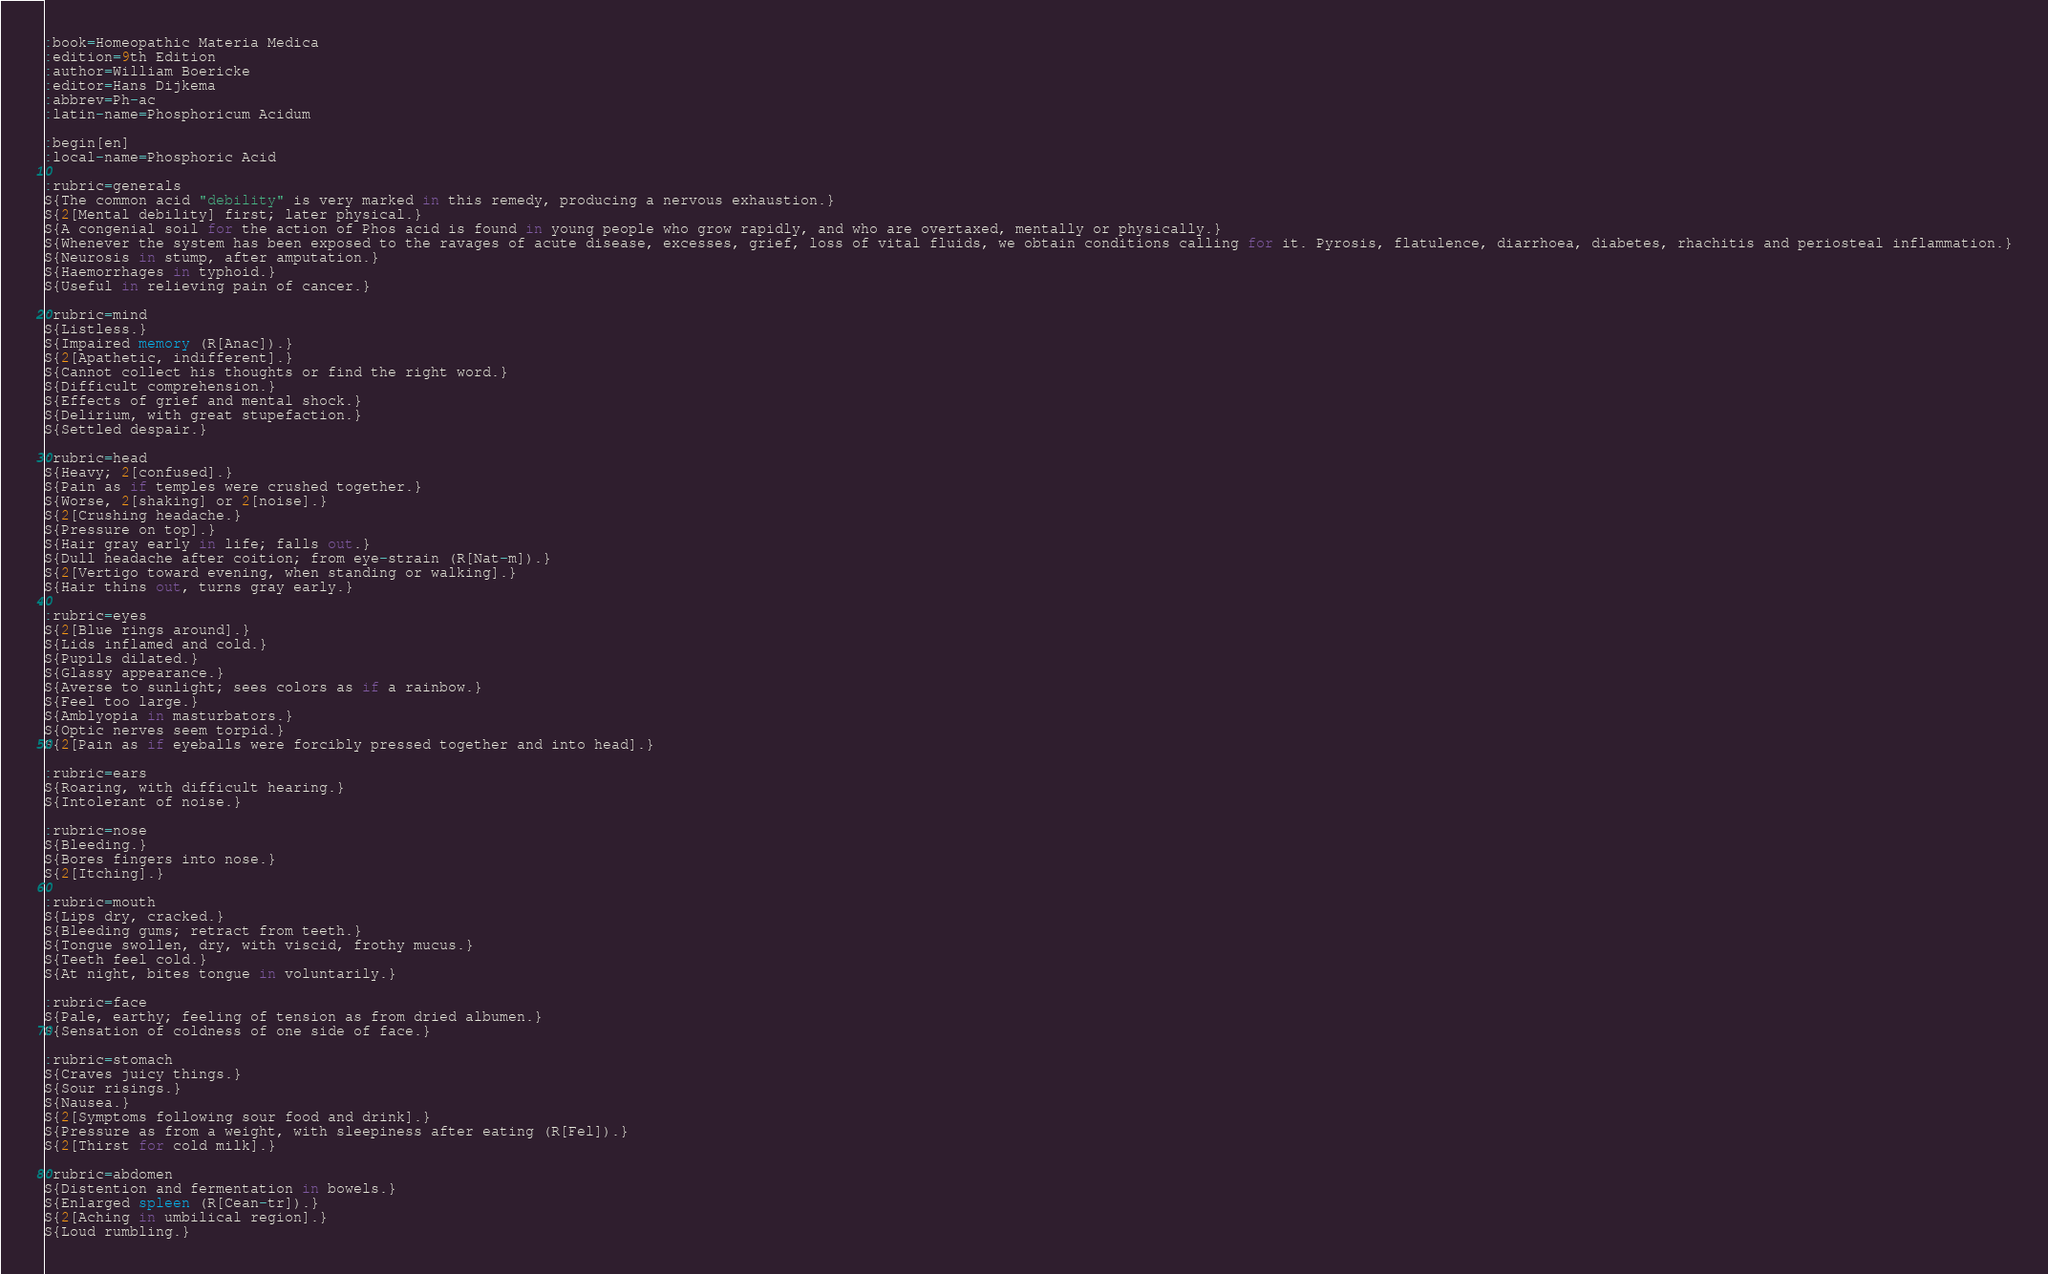Convert code to text. <code><loc_0><loc_0><loc_500><loc_500><_ObjectiveC_>:book=Homeopathic Materia Medica
:edition=9th Edition
:author=William Boericke
:editor=Hans Dijkema
:abbrev=Ph-ac
:latin-name=Phosphoricum Acidum

:begin[en]
:local-name=Phosphoric Acid

:rubric=generals
S{The common acid "debility" is very marked in this remedy, producing a nervous exhaustion.}
S{2[Mental debility] first; later physical.}
S{A congenial soil for the action of Phos acid is found in young people who grow rapidly, and who are overtaxed, mentally or physically.}
S{Whenever the system has been exposed to the ravages of acute disease, excesses, grief, loss of vital fluids, we obtain conditions calling for it. Pyrosis, flatulence, diarrhoea, diabetes, rhachitis and periosteal inflammation.}
S{Neurosis in stump, after amputation.}
S{Haemorrhages in typhoid.}
S{Useful in relieving pain of cancer.}

:rubric=mind
S{Listless.}
S{Impaired memory (R[Anac]).}
S{2[Apathetic, indifferent].}
S{Cannot collect his thoughts or find the right word.}
S{Difficult comprehension.}
S{Effects of grief and mental shock.}
S{Delirium, with great stupefaction.}
S{Settled despair.}

:rubric=head
S{Heavy; 2[confused].}
S{Pain as if temples were crushed together.}
S{Worse, 2[shaking] or 2[noise].}
S{2[Crushing headache.}
S{Pressure on top].}
S{Hair gray early in life; falls out.}
S{Dull headache after coition; from eye-strain (R[Nat-m]).}
S{2[Vertigo toward evening, when standing or walking].}
S{Hair thins out, turns gray early.}

:rubric=eyes
S{2[Blue rings around].}
S{Lids inflamed and cold.}
S{Pupils dilated.}
S{Glassy appearance.}
S{Averse to sunlight; sees colors as if a rainbow.}
S{Feel too large.}
S{Amblyopia in masturbators.}
S{Optic nerves seem torpid.}
S{2[Pain as if eyeballs were forcibly pressed together and into head].}

:rubric=ears
S{Roaring, with difficult hearing.}
S{Intolerant of noise.}

:rubric=nose
S{Bleeding.}
S{Bores fingers into nose.}
S{2[Itching].}

:rubric=mouth
S{Lips dry, cracked.}
S{Bleeding gums; retract from teeth.}
S{Tongue swollen, dry, with viscid, frothy mucus.}
S{Teeth feel cold.}
S{At night, bites tongue in voluntarily.}

:rubric=face
S{Pale, earthy; feeling of tension as from dried albumen.}
S{Sensation of coldness of one side of face.}

:rubric=stomach
S{Craves juicy things.}
S{Sour risings.}
S{Nausea.}
S{2[Symptoms following sour food and drink].}
S{Pressure as from a weight, with sleepiness after eating (R[Fel]).}
S{2[Thirst for cold milk].}

:rubric=abdomen
S{Distention and fermentation in bowels.}
S{Enlarged spleen (R[Cean-tr]).}
S{2[Aching in umbilical region].}
S{Loud rumbling.}
</code> 